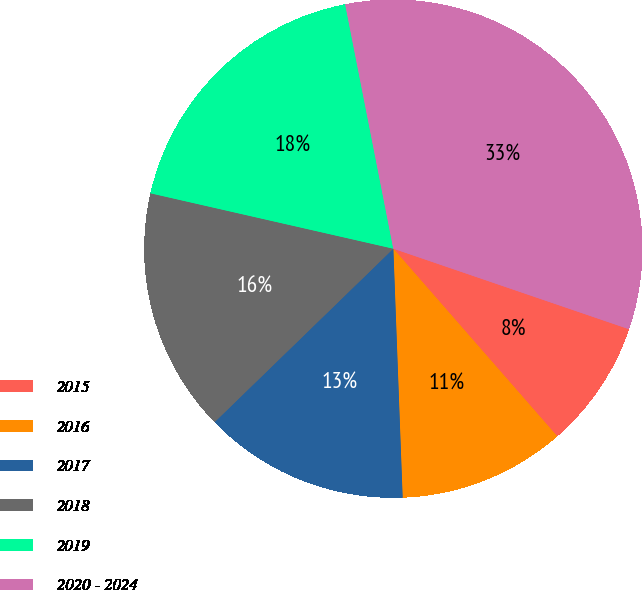<chart> <loc_0><loc_0><loc_500><loc_500><pie_chart><fcel>2015<fcel>2016<fcel>2017<fcel>2018<fcel>2019<fcel>2020 - 2024<nl><fcel>8.33%<fcel>10.83%<fcel>13.33%<fcel>15.83%<fcel>18.33%<fcel>33.33%<nl></chart> 